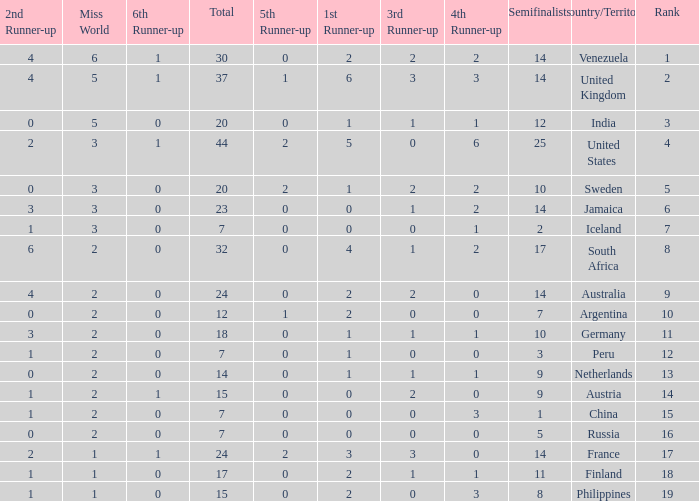What is Venezuela's total rank? 30.0. 